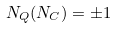<formula> <loc_0><loc_0><loc_500><loc_500>N _ { Q } ( N _ { C } ) = \pm 1</formula> 